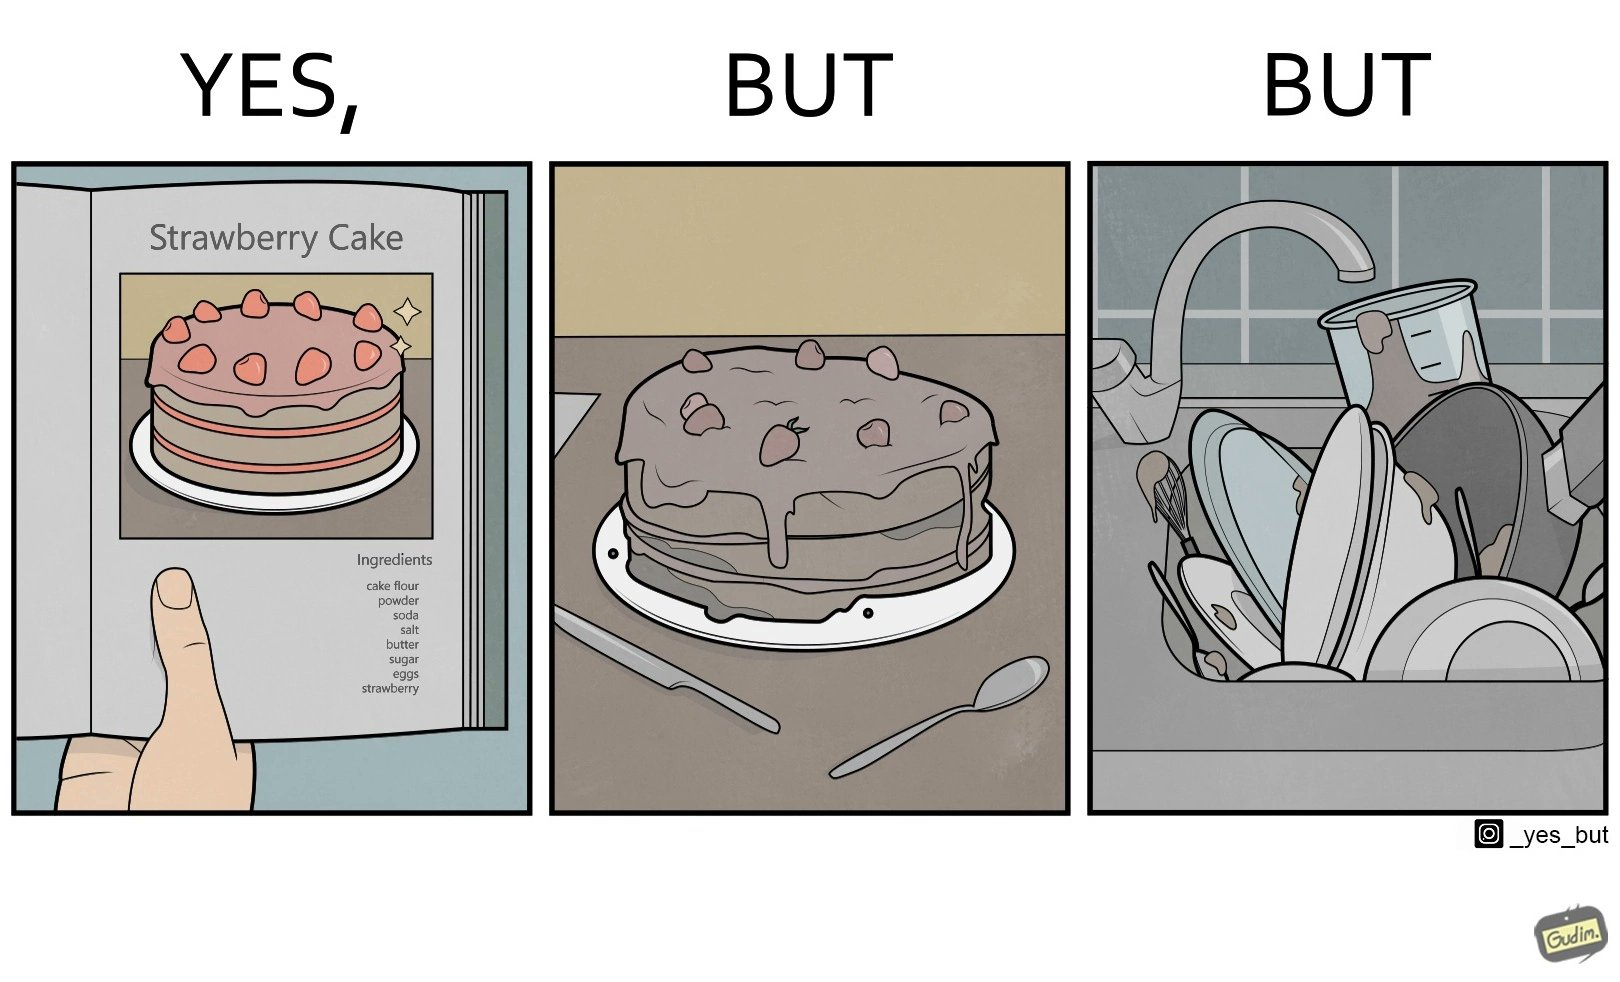Explain the humor or irony in this image. The image is funny, as when making a strawberry cake using  a recipe book, the outcome is not quite what is expected, and one has to wash the used utensils afterwards as well. 